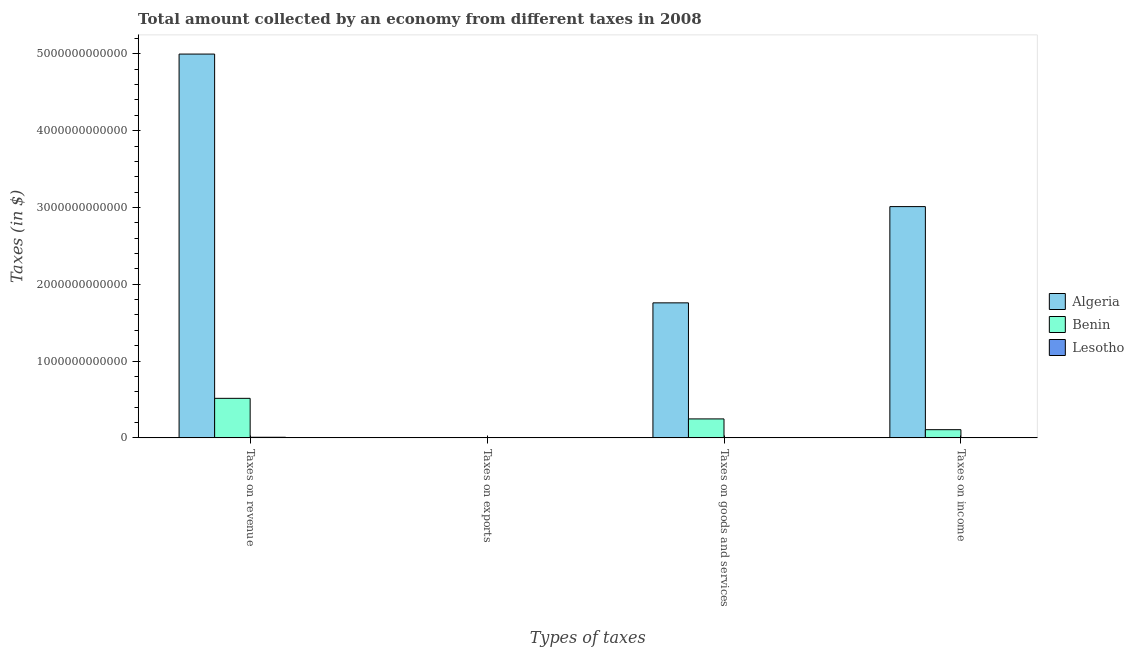How many different coloured bars are there?
Make the answer very short. 3. Are the number of bars per tick equal to the number of legend labels?
Keep it short and to the point. Yes. Are the number of bars on each tick of the X-axis equal?
Ensure brevity in your answer.  Yes. How many bars are there on the 4th tick from the right?
Make the answer very short. 3. What is the label of the 1st group of bars from the left?
Ensure brevity in your answer.  Taxes on revenue. What is the amount collected as tax on income in Algeria?
Provide a short and direct response. 3.01e+12. Across all countries, what is the maximum amount collected as tax on goods?
Give a very brief answer. 1.76e+12. Across all countries, what is the minimum amount collected as tax on exports?
Keep it short and to the point. 1.39e+08. In which country was the amount collected as tax on exports maximum?
Your answer should be compact. Benin. In which country was the amount collected as tax on revenue minimum?
Provide a succinct answer. Lesotho. What is the total amount collected as tax on goods in the graph?
Offer a terse response. 2.01e+12. What is the difference between the amount collected as tax on revenue in Algeria and that in Benin?
Make the answer very short. 4.48e+12. What is the difference between the amount collected as tax on revenue in Lesotho and the amount collected as tax on goods in Algeria?
Offer a terse response. -1.75e+12. What is the average amount collected as tax on revenue per country?
Give a very brief answer. 1.84e+12. What is the difference between the amount collected as tax on goods and amount collected as tax on revenue in Algeria?
Provide a succinct answer. -3.24e+12. What is the ratio of the amount collected as tax on revenue in Algeria to that in Benin?
Make the answer very short. 9.71. Is the amount collected as tax on goods in Benin less than that in Algeria?
Your response must be concise. Yes. Is the difference between the amount collected as tax on goods in Algeria and Benin greater than the difference between the amount collected as tax on revenue in Algeria and Benin?
Make the answer very short. No. What is the difference between the highest and the second highest amount collected as tax on goods?
Your answer should be compact. 1.51e+12. What is the difference between the highest and the lowest amount collected as tax on goods?
Your answer should be very brief. 1.76e+12. What does the 2nd bar from the left in Taxes on income represents?
Offer a terse response. Benin. What does the 1st bar from the right in Taxes on goods and services represents?
Offer a terse response. Lesotho. Is it the case that in every country, the sum of the amount collected as tax on revenue and amount collected as tax on exports is greater than the amount collected as tax on goods?
Keep it short and to the point. Yes. How many bars are there?
Give a very brief answer. 12. Are all the bars in the graph horizontal?
Your answer should be compact. No. How many countries are there in the graph?
Provide a succinct answer. 3. What is the difference between two consecutive major ticks on the Y-axis?
Keep it short and to the point. 1.00e+12. What is the title of the graph?
Keep it short and to the point. Total amount collected by an economy from different taxes in 2008. What is the label or title of the X-axis?
Offer a terse response. Types of taxes. What is the label or title of the Y-axis?
Provide a succinct answer. Taxes (in $). What is the Taxes (in $) of Algeria in Taxes on revenue?
Ensure brevity in your answer.  5.00e+12. What is the Taxes (in $) of Benin in Taxes on revenue?
Provide a short and direct response. 5.15e+11. What is the Taxes (in $) of Lesotho in Taxes on revenue?
Offer a very short reply. 7.91e+09. What is the Taxes (in $) of Algeria in Taxes on exports?
Offer a very short reply. 7.70e+08. What is the Taxes (in $) of Benin in Taxes on exports?
Give a very brief answer. 3.27e+09. What is the Taxes (in $) in Lesotho in Taxes on exports?
Your response must be concise. 1.39e+08. What is the Taxes (in $) in Algeria in Taxes on goods and services?
Provide a succinct answer. 1.76e+12. What is the Taxes (in $) in Benin in Taxes on goods and services?
Your answer should be very brief. 2.47e+11. What is the Taxes (in $) of Lesotho in Taxes on goods and services?
Your answer should be very brief. 1.10e+09. What is the Taxes (in $) in Algeria in Taxes on income?
Your response must be concise. 3.01e+12. What is the Taxes (in $) in Benin in Taxes on income?
Offer a very short reply. 1.07e+11. What is the Taxes (in $) in Lesotho in Taxes on income?
Offer a very short reply. 1.54e+09. Across all Types of taxes, what is the maximum Taxes (in $) of Algeria?
Provide a short and direct response. 5.00e+12. Across all Types of taxes, what is the maximum Taxes (in $) of Benin?
Keep it short and to the point. 5.15e+11. Across all Types of taxes, what is the maximum Taxes (in $) in Lesotho?
Make the answer very short. 7.91e+09. Across all Types of taxes, what is the minimum Taxes (in $) in Algeria?
Give a very brief answer. 7.70e+08. Across all Types of taxes, what is the minimum Taxes (in $) in Benin?
Provide a succinct answer. 3.27e+09. Across all Types of taxes, what is the minimum Taxes (in $) of Lesotho?
Your answer should be very brief. 1.39e+08. What is the total Taxes (in $) of Algeria in the graph?
Your response must be concise. 9.77e+12. What is the total Taxes (in $) of Benin in the graph?
Ensure brevity in your answer.  8.72e+11. What is the total Taxes (in $) in Lesotho in the graph?
Give a very brief answer. 1.07e+1. What is the difference between the Taxes (in $) in Algeria in Taxes on revenue and that in Taxes on exports?
Offer a very short reply. 5.00e+12. What is the difference between the Taxes (in $) in Benin in Taxes on revenue and that in Taxes on exports?
Keep it short and to the point. 5.11e+11. What is the difference between the Taxes (in $) in Lesotho in Taxes on revenue and that in Taxes on exports?
Your response must be concise. 7.77e+09. What is the difference between the Taxes (in $) in Algeria in Taxes on revenue and that in Taxes on goods and services?
Your response must be concise. 3.24e+12. What is the difference between the Taxes (in $) in Benin in Taxes on revenue and that in Taxes on goods and services?
Your answer should be compact. 2.68e+11. What is the difference between the Taxes (in $) in Lesotho in Taxes on revenue and that in Taxes on goods and services?
Offer a terse response. 6.81e+09. What is the difference between the Taxes (in $) of Algeria in Taxes on revenue and that in Taxes on income?
Give a very brief answer. 1.99e+12. What is the difference between the Taxes (in $) in Benin in Taxes on revenue and that in Taxes on income?
Your answer should be compact. 4.08e+11. What is the difference between the Taxes (in $) of Lesotho in Taxes on revenue and that in Taxes on income?
Keep it short and to the point. 6.36e+09. What is the difference between the Taxes (in $) in Algeria in Taxes on exports and that in Taxes on goods and services?
Offer a terse response. -1.76e+12. What is the difference between the Taxes (in $) of Benin in Taxes on exports and that in Taxes on goods and services?
Provide a short and direct response. -2.44e+11. What is the difference between the Taxes (in $) of Lesotho in Taxes on exports and that in Taxes on goods and services?
Keep it short and to the point. -9.58e+08. What is the difference between the Taxes (in $) in Algeria in Taxes on exports and that in Taxes on income?
Your response must be concise. -3.01e+12. What is the difference between the Taxes (in $) of Benin in Taxes on exports and that in Taxes on income?
Provide a short and direct response. -1.03e+11. What is the difference between the Taxes (in $) of Lesotho in Taxes on exports and that in Taxes on income?
Ensure brevity in your answer.  -1.40e+09. What is the difference between the Taxes (in $) in Algeria in Taxes on goods and services and that in Taxes on income?
Your answer should be very brief. -1.25e+12. What is the difference between the Taxes (in $) of Benin in Taxes on goods and services and that in Taxes on income?
Offer a terse response. 1.40e+11. What is the difference between the Taxes (in $) of Lesotho in Taxes on goods and services and that in Taxes on income?
Give a very brief answer. -4.45e+08. What is the difference between the Taxes (in $) of Algeria in Taxes on revenue and the Taxes (in $) of Benin in Taxes on exports?
Provide a short and direct response. 4.99e+12. What is the difference between the Taxes (in $) of Algeria in Taxes on revenue and the Taxes (in $) of Lesotho in Taxes on exports?
Offer a very short reply. 5.00e+12. What is the difference between the Taxes (in $) of Benin in Taxes on revenue and the Taxes (in $) of Lesotho in Taxes on exports?
Your answer should be compact. 5.15e+11. What is the difference between the Taxes (in $) of Algeria in Taxes on revenue and the Taxes (in $) of Benin in Taxes on goods and services?
Provide a short and direct response. 4.75e+12. What is the difference between the Taxes (in $) in Algeria in Taxes on revenue and the Taxes (in $) in Lesotho in Taxes on goods and services?
Provide a short and direct response. 5.00e+12. What is the difference between the Taxes (in $) of Benin in Taxes on revenue and the Taxes (in $) of Lesotho in Taxes on goods and services?
Your answer should be very brief. 5.14e+11. What is the difference between the Taxes (in $) of Algeria in Taxes on revenue and the Taxes (in $) of Benin in Taxes on income?
Offer a terse response. 4.89e+12. What is the difference between the Taxes (in $) in Algeria in Taxes on revenue and the Taxes (in $) in Lesotho in Taxes on income?
Keep it short and to the point. 5.00e+12. What is the difference between the Taxes (in $) of Benin in Taxes on revenue and the Taxes (in $) of Lesotho in Taxes on income?
Your answer should be compact. 5.13e+11. What is the difference between the Taxes (in $) in Algeria in Taxes on exports and the Taxes (in $) in Benin in Taxes on goods and services?
Provide a succinct answer. -2.46e+11. What is the difference between the Taxes (in $) of Algeria in Taxes on exports and the Taxes (in $) of Lesotho in Taxes on goods and services?
Provide a short and direct response. -3.28e+08. What is the difference between the Taxes (in $) of Benin in Taxes on exports and the Taxes (in $) of Lesotho in Taxes on goods and services?
Your answer should be very brief. 2.17e+09. What is the difference between the Taxes (in $) of Algeria in Taxes on exports and the Taxes (in $) of Benin in Taxes on income?
Your response must be concise. -1.06e+11. What is the difference between the Taxes (in $) of Algeria in Taxes on exports and the Taxes (in $) of Lesotho in Taxes on income?
Provide a short and direct response. -7.73e+08. What is the difference between the Taxes (in $) of Benin in Taxes on exports and the Taxes (in $) of Lesotho in Taxes on income?
Give a very brief answer. 1.72e+09. What is the difference between the Taxes (in $) of Algeria in Taxes on goods and services and the Taxes (in $) of Benin in Taxes on income?
Keep it short and to the point. 1.65e+12. What is the difference between the Taxes (in $) of Algeria in Taxes on goods and services and the Taxes (in $) of Lesotho in Taxes on income?
Give a very brief answer. 1.76e+12. What is the difference between the Taxes (in $) in Benin in Taxes on goods and services and the Taxes (in $) in Lesotho in Taxes on income?
Your answer should be compact. 2.45e+11. What is the average Taxes (in $) in Algeria per Types of taxes?
Your answer should be very brief. 2.44e+12. What is the average Taxes (in $) of Benin per Types of taxes?
Offer a very short reply. 2.18e+11. What is the average Taxes (in $) in Lesotho per Types of taxes?
Your response must be concise. 2.67e+09. What is the difference between the Taxes (in $) of Algeria and Taxes (in $) of Benin in Taxes on revenue?
Offer a very short reply. 4.48e+12. What is the difference between the Taxes (in $) in Algeria and Taxes (in $) in Lesotho in Taxes on revenue?
Your answer should be very brief. 4.99e+12. What is the difference between the Taxes (in $) of Benin and Taxes (in $) of Lesotho in Taxes on revenue?
Offer a terse response. 5.07e+11. What is the difference between the Taxes (in $) of Algeria and Taxes (in $) of Benin in Taxes on exports?
Provide a short and direct response. -2.50e+09. What is the difference between the Taxes (in $) in Algeria and Taxes (in $) in Lesotho in Taxes on exports?
Keep it short and to the point. 6.31e+08. What is the difference between the Taxes (in $) of Benin and Taxes (in $) of Lesotho in Taxes on exports?
Provide a short and direct response. 3.13e+09. What is the difference between the Taxes (in $) in Algeria and Taxes (in $) in Benin in Taxes on goods and services?
Ensure brevity in your answer.  1.51e+12. What is the difference between the Taxes (in $) in Algeria and Taxes (in $) in Lesotho in Taxes on goods and services?
Ensure brevity in your answer.  1.76e+12. What is the difference between the Taxes (in $) in Benin and Taxes (in $) in Lesotho in Taxes on goods and services?
Make the answer very short. 2.46e+11. What is the difference between the Taxes (in $) in Algeria and Taxes (in $) in Benin in Taxes on income?
Provide a succinct answer. 2.90e+12. What is the difference between the Taxes (in $) of Algeria and Taxes (in $) of Lesotho in Taxes on income?
Your answer should be very brief. 3.01e+12. What is the difference between the Taxes (in $) of Benin and Taxes (in $) of Lesotho in Taxes on income?
Offer a terse response. 1.05e+11. What is the ratio of the Taxes (in $) in Algeria in Taxes on revenue to that in Taxes on exports?
Your response must be concise. 6490.39. What is the ratio of the Taxes (in $) of Benin in Taxes on revenue to that in Taxes on exports?
Your response must be concise. 157.54. What is the ratio of the Taxes (in $) in Lesotho in Taxes on revenue to that in Taxes on exports?
Offer a very short reply. 56.8. What is the ratio of the Taxes (in $) of Algeria in Taxes on revenue to that in Taxes on goods and services?
Make the answer very short. 2.84. What is the ratio of the Taxes (in $) in Benin in Taxes on revenue to that in Taxes on goods and services?
Offer a terse response. 2.08. What is the ratio of the Taxes (in $) in Lesotho in Taxes on revenue to that in Taxes on goods and services?
Provide a succinct answer. 7.2. What is the ratio of the Taxes (in $) in Algeria in Taxes on revenue to that in Taxes on income?
Offer a very short reply. 1.66. What is the ratio of the Taxes (in $) in Benin in Taxes on revenue to that in Taxes on income?
Keep it short and to the point. 4.83. What is the ratio of the Taxes (in $) in Lesotho in Taxes on revenue to that in Taxes on income?
Your response must be concise. 5.12. What is the ratio of the Taxes (in $) of Benin in Taxes on exports to that in Taxes on goods and services?
Keep it short and to the point. 0.01. What is the ratio of the Taxes (in $) of Lesotho in Taxes on exports to that in Taxes on goods and services?
Provide a short and direct response. 0.13. What is the ratio of the Taxes (in $) in Algeria in Taxes on exports to that in Taxes on income?
Provide a short and direct response. 0. What is the ratio of the Taxes (in $) in Benin in Taxes on exports to that in Taxes on income?
Give a very brief answer. 0.03. What is the ratio of the Taxes (in $) in Lesotho in Taxes on exports to that in Taxes on income?
Give a very brief answer. 0.09. What is the ratio of the Taxes (in $) of Algeria in Taxes on goods and services to that in Taxes on income?
Your answer should be very brief. 0.58. What is the ratio of the Taxes (in $) in Benin in Taxes on goods and services to that in Taxes on income?
Offer a very short reply. 2.31. What is the ratio of the Taxes (in $) of Lesotho in Taxes on goods and services to that in Taxes on income?
Keep it short and to the point. 0.71. What is the difference between the highest and the second highest Taxes (in $) of Algeria?
Keep it short and to the point. 1.99e+12. What is the difference between the highest and the second highest Taxes (in $) in Benin?
Keep it short and to the point. 2.68e+11. What is the difference between the highest and the second highest Taxes (in $) in Lesotho?
Offer a terse response. 6.36e+09. What is the difference between the highest and the lowest Taxes (in $) of Algeria?
Your answer should be compact. 5.00e+12. What is the difference between the highest and the lowest Taxes (in $) in Benin?
Provide a short and direct response. 5.11e+11. What is the difference between the highest and the lowest Taxes (in $) in Lesotho?
Ensure brevity in your answer.  7.77e+09. 